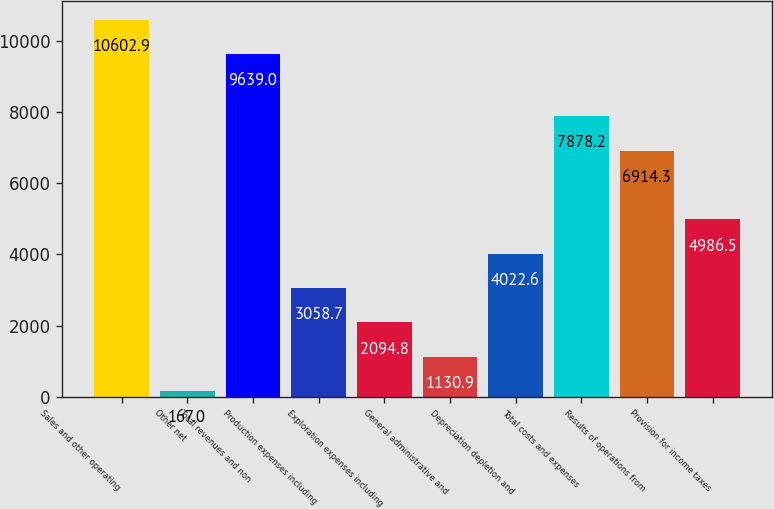<chart> <loc_0><loc_0><loc_500><loc_500><bar_chart><fcel>Sales and other operating<fcel>Other net<fcel>Total revenues and non<fcel>Production expenses including<fcel>Exploration expenses including<fcel>General administrative and<fcel>Depreciation depletion and<fcel>Total costs and expenses<fcel>Results of operations from<fcel>Provision for income taxes<nl><fcel>10602.9<fcel>167<fcel>9639<fcel>3058.7<fcel>2094.8<fcel>1130.9<fcel>4022.6<fcel>7878.2<fcel>6914.3<fcel>4986.5<nl></chart> 